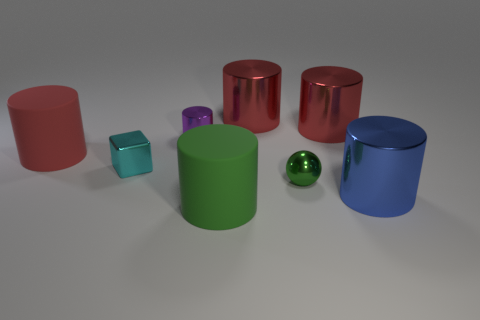What number of large things are brown cylinders or green metallic objects? Upon reviewing the image, there appear to be no brown cylinders; however, there is one large green metallic-like object, which is a green cylinder. If we count it as a green metallic object, the number would be 1. 